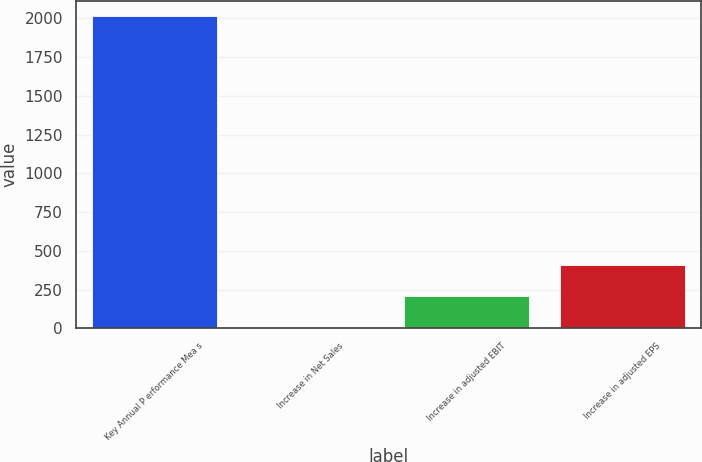<chart> <loc_0><loc_0><loc_500><loc_500><bar_chart><fcel>Key Annual P erformance Mea s<fcel>Increase in Net Sales<fcel>Increase in adjusted EBIT<fcel>Increase in adjusted EPS<nl><fcel>2012<fcel>9.3<fcel>209.57<fcel>409.84<nl></chart> 